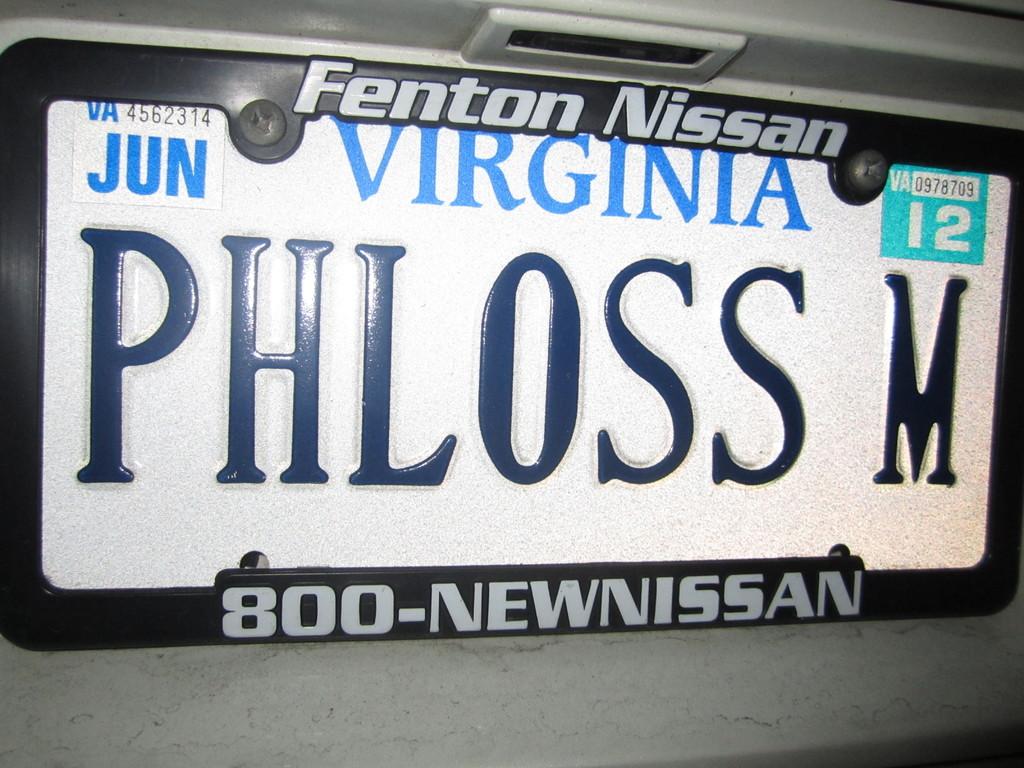What state is this license plate from?
Keep it short and to the point. Virginia. What is the name of the state?
Ensure brevity in your answer.  Virginia. 